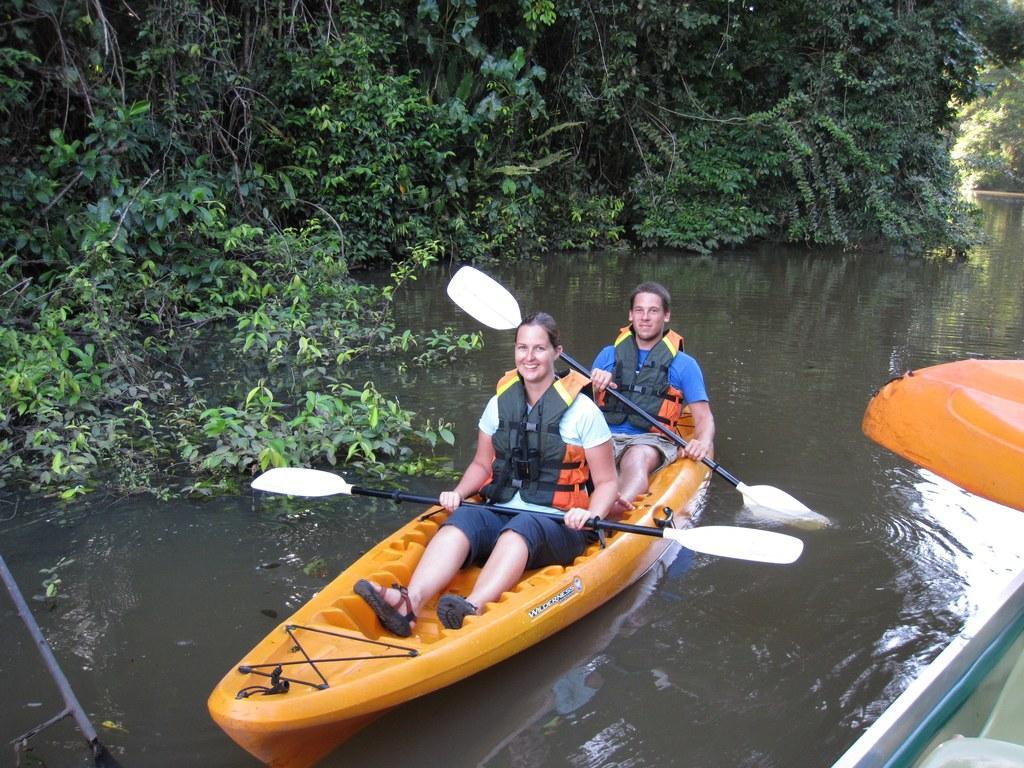In one or two sentences, can you explain what this image depicts? In this picture we can see two people sitting on a boat and holding paddles in their hands. This boat is in water. We can see a stand on the left side. There are some trees in the background. 